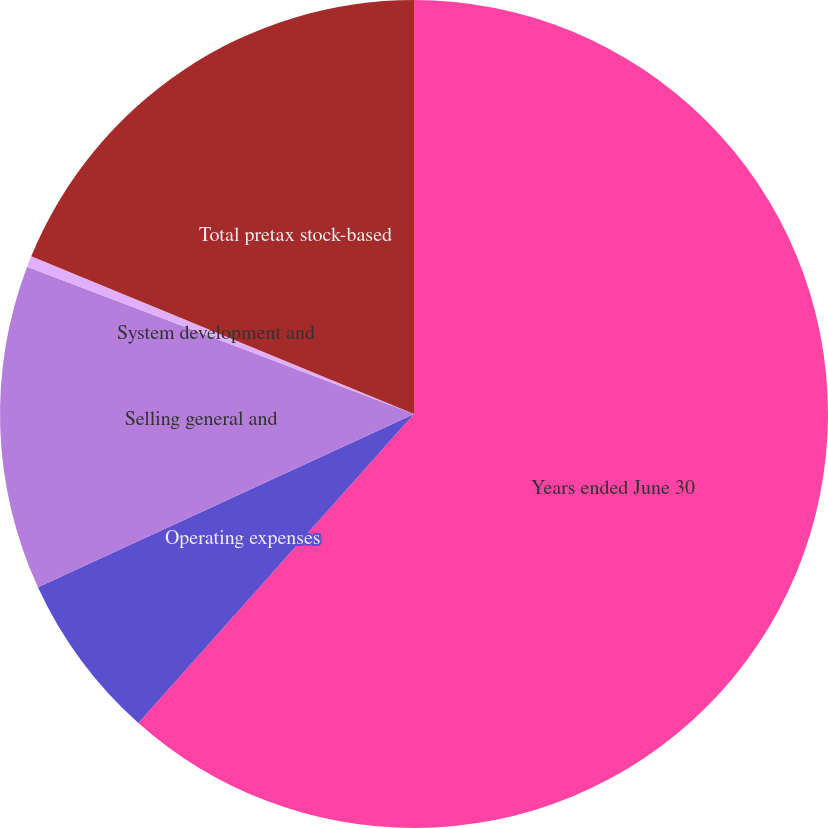<chart> <loc_0><loc_0><loc_500><loc_500><pie_chart><fcel>Years ended June 30<fcel>Operating expenses<fcel>Selling general and<fcel>System development and<fcel>Total pretax stock-based<nl><fcel>61.6%<fcel>6.54%<fcel>12.66%<fcel>0.43%<fcel>18.78%<nl></chart> 